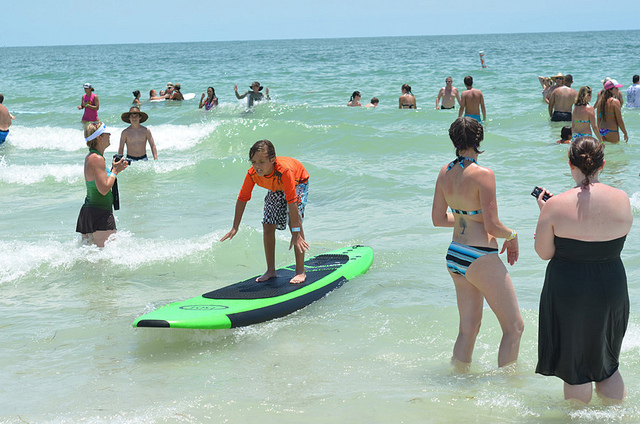What activity is the boy engaging in? The boy is surfing on a surfboard. Can you describe the surfboard? The surfboard is a bright green color with a black top surface. It appears to be designed for beginners, given its wide and stable shape. 